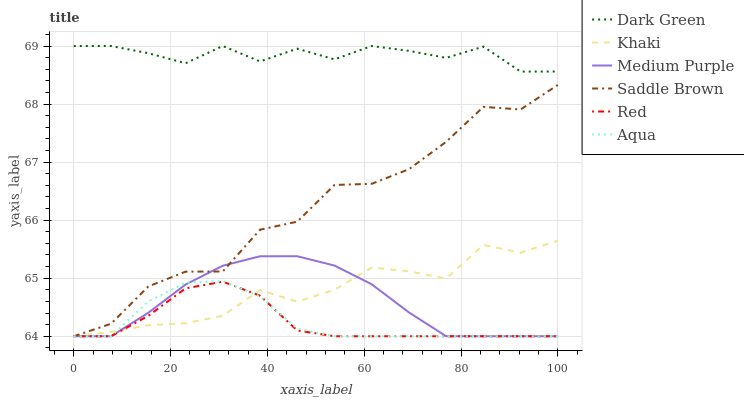Does Red have the minimum area under the curve?
Answer yes or no. Yes. Does Dark Green have the maximum area under the curve?
Answer yes or no. Yes. Does Aqua have the minimum area under the curve?
Answer yes or no. No. Does Aqua have the maximum area under the curve?
Answer yes or no. No. Is Medium Purple the smoothest?
Answer yes or no. Yes. Is Saddle Brown the roughest?
Answer yes or no. Yes. Is Aqua the smoothest?
Answer yes or no. No. Is Aqua the roughest?
Answer yes or no. No. Does Khaki have the lowest value?
Answer yes or no. Yes. Does Dark Green have the lowest value?
Answer yes or no. No. Does Dark Green have the highest value?
Answer yes or no. Yes. Does Aqua have the highest value?
Answer yes or no. No. Is Aqua less than Dark Green?
Answer yes or no. Yes. Is Dark Green greater than Medium Purple?
Answer yes or no. Yes. Does Aqua intersect Medium Purple?
Answer yes or no. Yes. Is Aqua less than Medium Purple?
Answer yes or no. No. Is Aqua greater than Medium Purple?
Answer yes or no. No. Does Aqua intersect Dark Green?
Answer yes or no. No. 